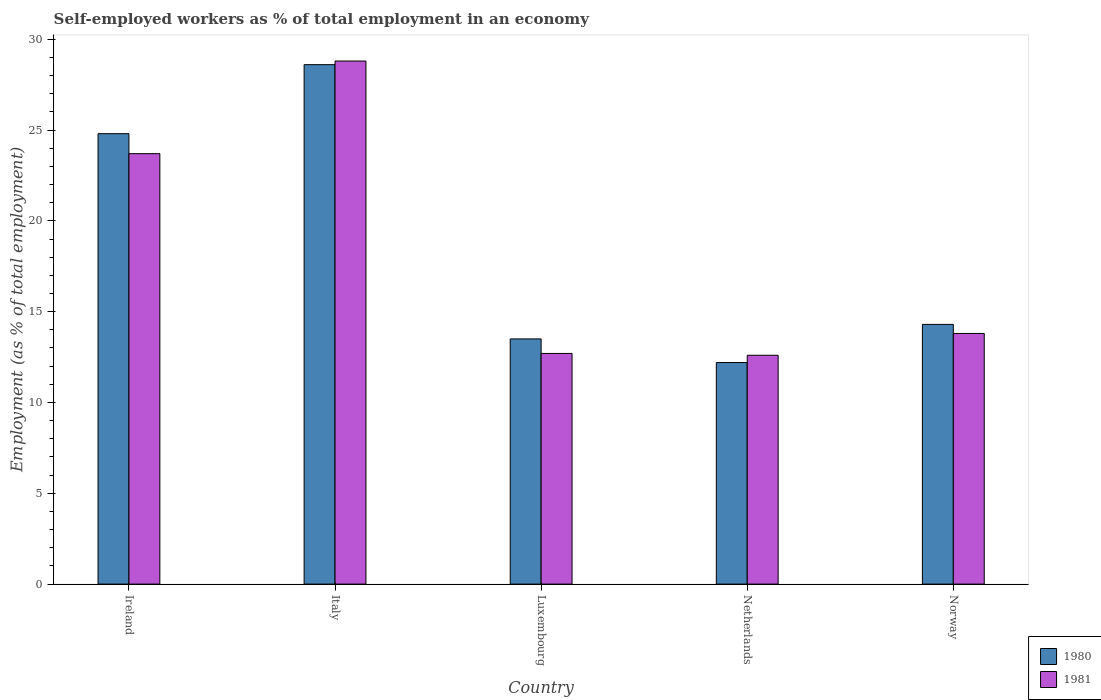How many different coloured bars are there?
Ensure brevity in your answer.  2. Are the number of bars per tick equal to the number of legend labels?
Keep it short and to the point. Yes. How many bars are there on the 3rd tick from the left?
Provide a short and direct response. 2. How many bars are there on the 1st tick from the right?
Your answer should be compact. 2. What is the label of the 3rd group of bars from the left?
Provide a succinct answer. Luxembourg. In how many cases, is the number of bars for a given country not equal to the number of legend labels?
Provide a succinct answer. 0. What is the percentage of self-employed workers in 1980 in Italy?
Keep it short and to the point. 28.6. Across all countries, what is the maximum percentage of self-employed workers in 1980?
Provide a short and direct response. 28.6. Across all countries, what is the minimum percentage of self-employed workers in 1980?
Your answer should be very brief. 12.2. In which country was the percentage of self-employed workers in 1981 maximum?
Make the answer very short. Italy. In which country was the percentage of self-employed workers in 1981 minimum?
Provide a short and direct response. Netherlands. What is the total percentage of self-employed workers in 1981 in the graph?
Your response must be concise. 91.6. What is the difference between the percentage of self-employed workers in 1981 in Ireland and that in Netherlands?
Your response must be concise. 11.1. What is the difference between the percentage of self-employed workers in 1980 in Luxembourg and the percentage of self-employed workers in 1981 in Italy?
Provide a succinct answer. -15.3. What is the average percentage of self-employed workers in 1981 per country?
Provide a short and direct response. 18.32. What is the difference between the percentage of self-employed workers of/in 1981 and percentage of self-employed workers of/in 1980 in Ireland?
Ensure brevity in your answer.  -1.1. What is the ratio of the percentage of self-employed workers in 1980 in Netherlands to that in Norway?
Make the answer very short. 0.85. What is the difference between the highest and the second highest percentage of self-employed workers in 1981?
Offer a terse response. 15. What is the difference between the highest and the lowest percentage of self-employed workers in 1981?
Offer a terse response. 16.2. Is the sum of the percentage of self-employed workers in 1981 in Netherlands and Norway greater than the maximum percentage of self-employed workers in 1980 across all countries?
Make the answer very short. No. What does the 2nd bar from the right in Norway represents?
Provide a succinct answer. 1980. What is the difference between two consecutive major ticks on the Y-axis?
Provide a short and direct response. 5. Are the values on the major ticks of Y-axis written in scientific E-notation?
Keep it short and to the point. No. Does the graph contain any zero values?
Ensure brevity in your answer.  No. Does the graph contain grids?
Give a very brief answer. No. Where does the legend appear in the graph?
Your response must be concise. Bottom right. How many legend labels are there?
Provide a short and direct response. 2. How are the legend labels stacked?
Your answer should be very brief. Vertical. What is the title of the graph?
Your answer should be compact. Self-employed workers as % of total employment in an economy. Does "1963" appear as one of the legend labels in the graph?
Provide a short and direct response. No. What is the label or title of the Y-axis?
Offer a very short reply. Employment (as % of total employment). What is the Employment (as % of total employment) of 1980 in Ireland?
Offer a terse response. 24.8. What is the Employment (as % of total employment) in 1981 in Ireland?
Offer a terse response. 23.7. What is the Employment (as % of total employment) of 1980 in Italy?
Provide a short and direct response. 28.6. What is the Employment (as % of total employment) of 1981 in Italy?
Provide a short and direct response. 28.8. What is the Employment (as % of total employment) of 1981 in Luxembourg?
Provide a short and direct response. 12.7. What is the Employment (as % of total employment) in 1980 in Netherlands?
Ensure brevity in your answer.  12.2. What is the Employment (as % of total employment) in 1981 in Netherlands?
Offer a terse response. 12.6. What is the Employment (as % of total employment) in 1980 in Norway?
Ensure brevity in your answer.  14.3. What is the Employment (as % of total employment) of 1981 in Norway?
Ensure brevity in your answer.  13.8. Across all countries, what is the maximum Employment (as % of total employment) of 1980?
Offer a very short reply. 28.6. Across all countries, what is the maximum Employment (as % of total employment) of 1981?
Your response must be concise. 28.8. Across all countries, what is the minimum Employment (as % of total employment) of 1980?
Offer a very short reply. 12.2. Across all countries, what is the minimum Employment (as % of total employment) in 1981?
Your answer should be compact. 12.6. What is the total Employment (as % of total employment) in 1980 in the graph?
Your answer should be very brief. 93.4. What is the total Employment (as % of total employment) in 1981 in the graph?
Your answer should be compact. 91.6. What is the difference between the Employment (as % of total employment) in 1980 in Ireland and that in Italy?
Give a very brief answer. -3.8. What is the difference between the Employment (as % of total employment) in 1981 in Ireland and that in Italy?
Provide a succinct answer. -5.1. What is the difference between the Employment (as % of total employment) of 1980 in Ireland and that in Luxembourg?
Provide a short and direct response. 11.3. What is the difference between the Employment (as % of total employment) in 1981 in Ireland and that in Luxembourg?
Keep it short and to the point. 11. What is the difference between the Employment (as % of total employment) of 1981 in Ireland and that in Netherlands?
Your answer should be very brief. 11.1. What is the difference between the Employment (as % of total employment) in 1980 in Italy and that in Netherlands?
Your answer should be compact. 16.4. What is the difference between the Employment (as % of total employment) in 1981 in Italy and that in Norway?
Your response must be concise. 15. What is the difference between the Employment (as % of total employment) in 1980 in Luxembourg and that in Norway?
Your answer should be very brief. -0.8. What is the difference between the Employment (as % of total employment) in 1981 in Netherlands and that in Norway?
Provide a short and direct response. -1.2. What is the difference between the Employment (as % of total employment) of 1980 in Ireland and the Employment (as % of total employment) of 1981 in Norway?
Make the answer very short. 11. What is the difference between the Employment (as % of total employment) of 1980 in Italy and the Employment (as % of total employment) of 1981 in Netherlands?
Offer a terse response. 16. What is the difference between the Employment (as % of total employment) in 1980 in Luxembourg and the Employment (as % of total employment) in 1981 in Norway?
Offer a terse response. -0.3. What is the difference between the Employment (as % of total employment) of 1980 in Netherlands and the Employment (as % of total employment) of 1981 in Norway?
Your answer should be compact. -1.6. What is the average Employment (as % of total employment) in 1980 per country?
Provide a succinct answer. 18.68. What is the average Employment (as % of total employment) of 1981 per country?
Provide a short and direct response. 18.32. What is the difference between the Employment (as % of total employment) in 1980 and Employment (as % of total employment) in 1981 in Italy?
Keep it short and to the point. -0.2. What is the ratio of the Employment (as % of total employment) of 1980 in Ireland to that in Italy?
Make the answer very short. 0.87. What is the ratio of the Employment (as % of total employment) in 1981 in Ireland to that in Italy?
Your response must be concise. 0.82. What is the ratio of the Employment (as % of total employment) of 1980 in Ireland to that in Luxembourg?
Provide a short and direct response. 1.84. What is the ratio of the Employment (as % of total employment) of 1981 in Ireland to that in Luxembourg?
Keep it short and to the point. 1.87. What is the ratio of the Employment (as % of total employment) in 1980 in Ireland to that in Netherlands?
Your answer should be very brief. 2.03. What is the ratio of the Employment (as % of total employment) in 1981 in Ireland to that in Netherlands?
Give a very brief answer. 1.88. What is the ratio of the Employment (as % of total employment) of 1980 in Ireland to that in Norway?
Give a very brief answer. 1.73. What is the ratio of the Employment (as % of total employment) in 1981 in Ireland to that in Norway?
Offer a very short reply. 1.72. What is the ratio of the Employment (as % of total employment) in 1980 in Italy to that in Luxembourg?
Offer a terse response. 2.12. What is the ratio of the Employment (as % of total employment) of 1981 in Italy to that in Luxembourg?
Give a very brief answer. 2.27. What is the ratio of the Employment (as % of total employment) in 1980 in Italy to that in Netherlands?
Offer a terse response. 2.34. What is the ratio of the Employment (as % of total employment) of 1981 in Italy to that in Netherlands?
Provide a short and direct response. 2.29. What is the ratio of the Employment (as % of total employment) of 1981 in Italy to that in Norway?
Your answer should be compact. 2.09. What is the ratio of the Employment (as % of total employment) in 1980 in Luxembourg to that in Netherlands?
Offer a terse response. 1.11. What is the ratio of the Employment (as % of total employment) of 1981 in Luxembourg to that in Netherlands?
Keep it short and to the point. 1.01. What is the ratio of the Employment (as % of total employment) of 1980 in Luxembourg to that in Norway?
Provide a short and direct response. 0.94. What is the ratio of the Employment (as % of total employment) of 1981 in Luxembourg to that in Norway?
Your answer should be very brief. 0.92. What is the ratio of the Employment (as % of total employment) in 1980 in Netherlands to that in Norway?
Ensure brevity in your answer.  0.85. What is the difference between the highest and the second highest Employment (as % of total employment) of 1980?
Offer a terse response. 3.8. What is the difference between the highest and the second highest Employment (as % of total employment) in 1981?
Give a very brief answer. 5.1. What is the difference between the highest and the lowest Employment (as % of total employment) of 1980?
Your response must be concise. 16.4. 